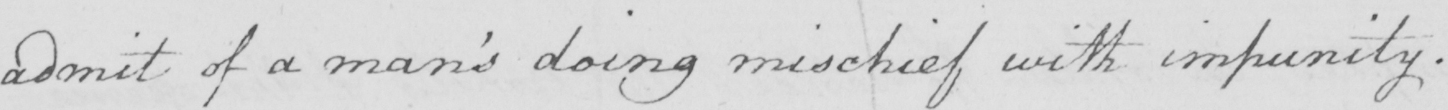Please transcribe the handwritten text in this image. admit of a man ' s doing mischief with impunity . 